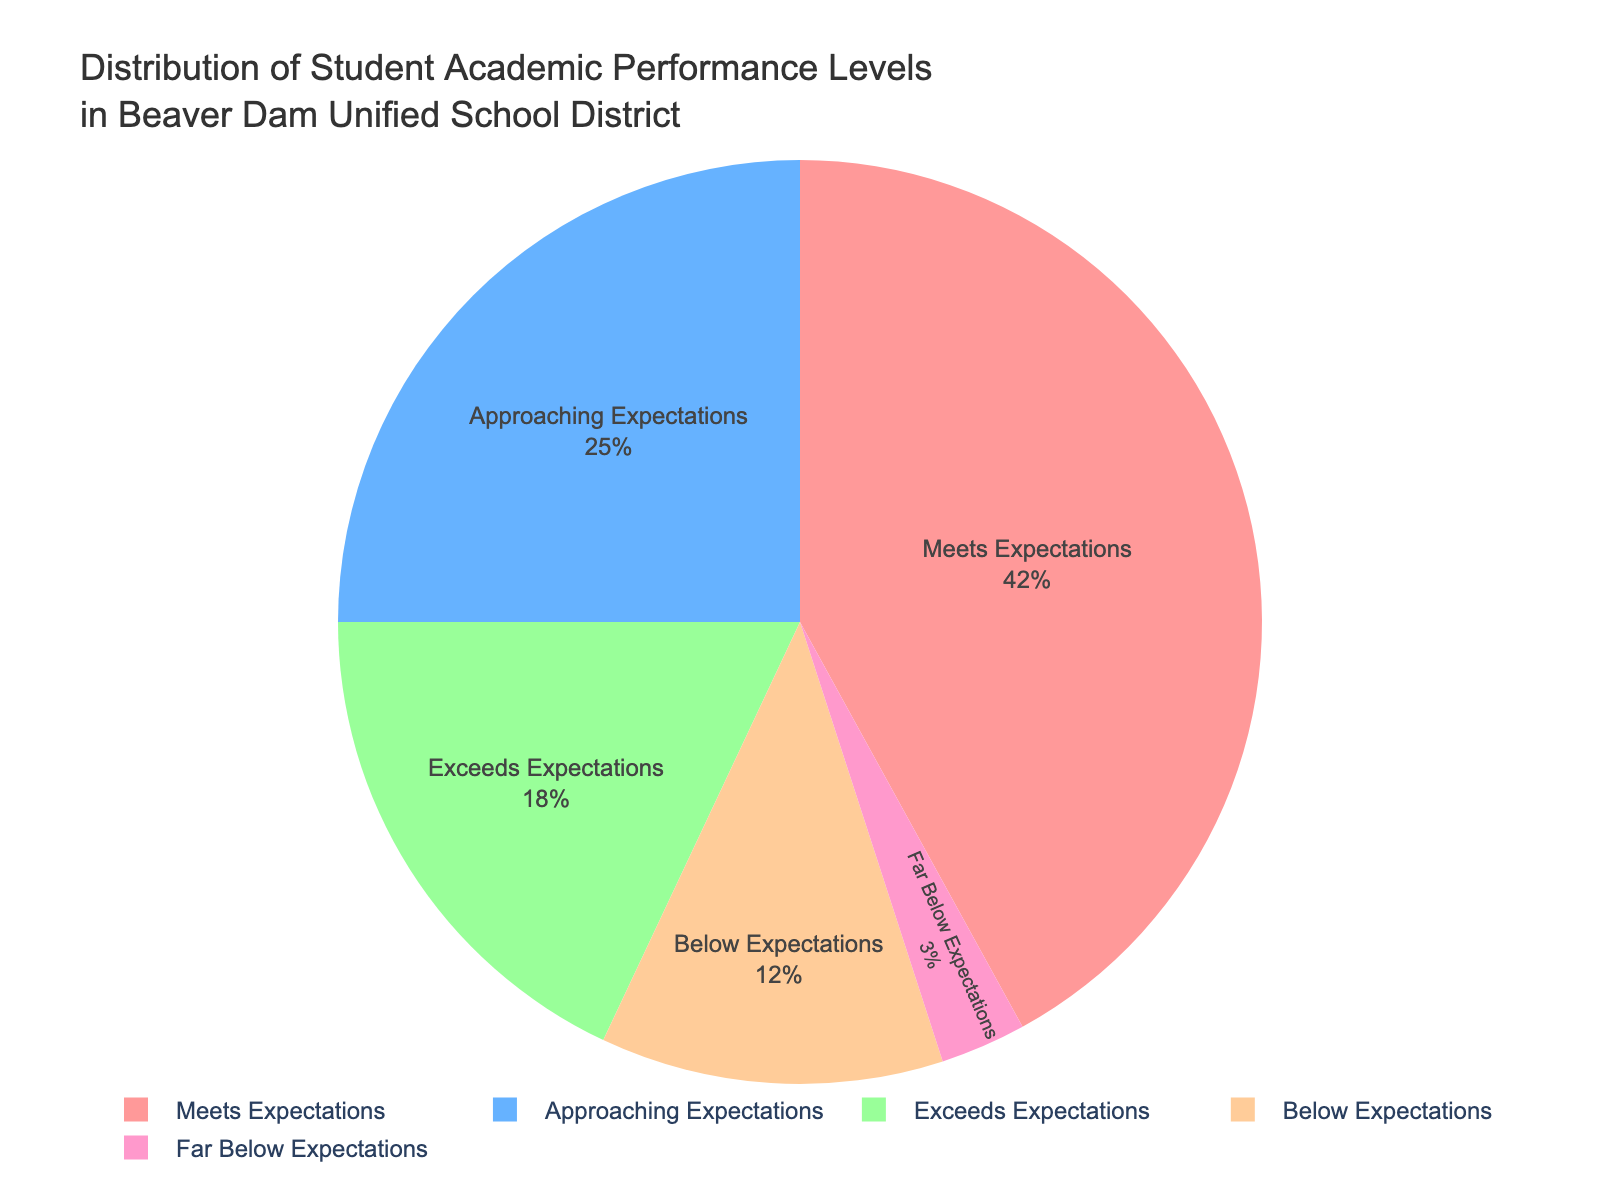What percentage of students are meeting or exceeding expectations? The segments "Meets Expectations" and "Exceeds Expectations" add up to 42% + 18% = 60%.
Answer: 60% What percentage of students falls below expectations? The segments "Below Expectations" and "Far Below Expectations" together make 12% + 3% = 15%.
Answer: 15% Which performance level has the highest percentage of students? The "Meets Expectations" segment has the highest percentage of 42%.
Answer: Meets Expectations What is the difference in percentage between students who are exceeding expectations and those who are below expectations? The difference is calculated as 18% (Exceeds) - 12% (Below) = 6%.
Answer: 6% How does the percentage of students approaching expectations compare to those far below expectations? The "Approaching Expectations" segment is 25%, whereas "Far Below Expectations" is 3%, making "Approaching Expectations" higher by 22%.
Answer: 22% What is the sum of the percentages for students who meet or exceed expectations and those who fall below or far below expectations? Sum of "Meets" + "Exceeds" + "Below" + "Far Below" is 42% + 18% + 12% + 3% = 75%.
Answer: 75% If 500 students were surveyed, how many students are meeting expectations? 42% of 500 students equals 0.42 * 500 = 210.
Answer: 210 What proportion of the total student population is performing at least at the "Approaching Expectations" level? Summing "Exceeds," "Meets," and "Approaching" gives 18% + 42% + 25% = 85%.
Answer: 85% What visual attribute helps you identify the "Meets Expectations" segment in the pie chart? The "Meets Expectations" segment is the largest and typically has a distinctive color making it easy to identify.
Answer: largest segment 